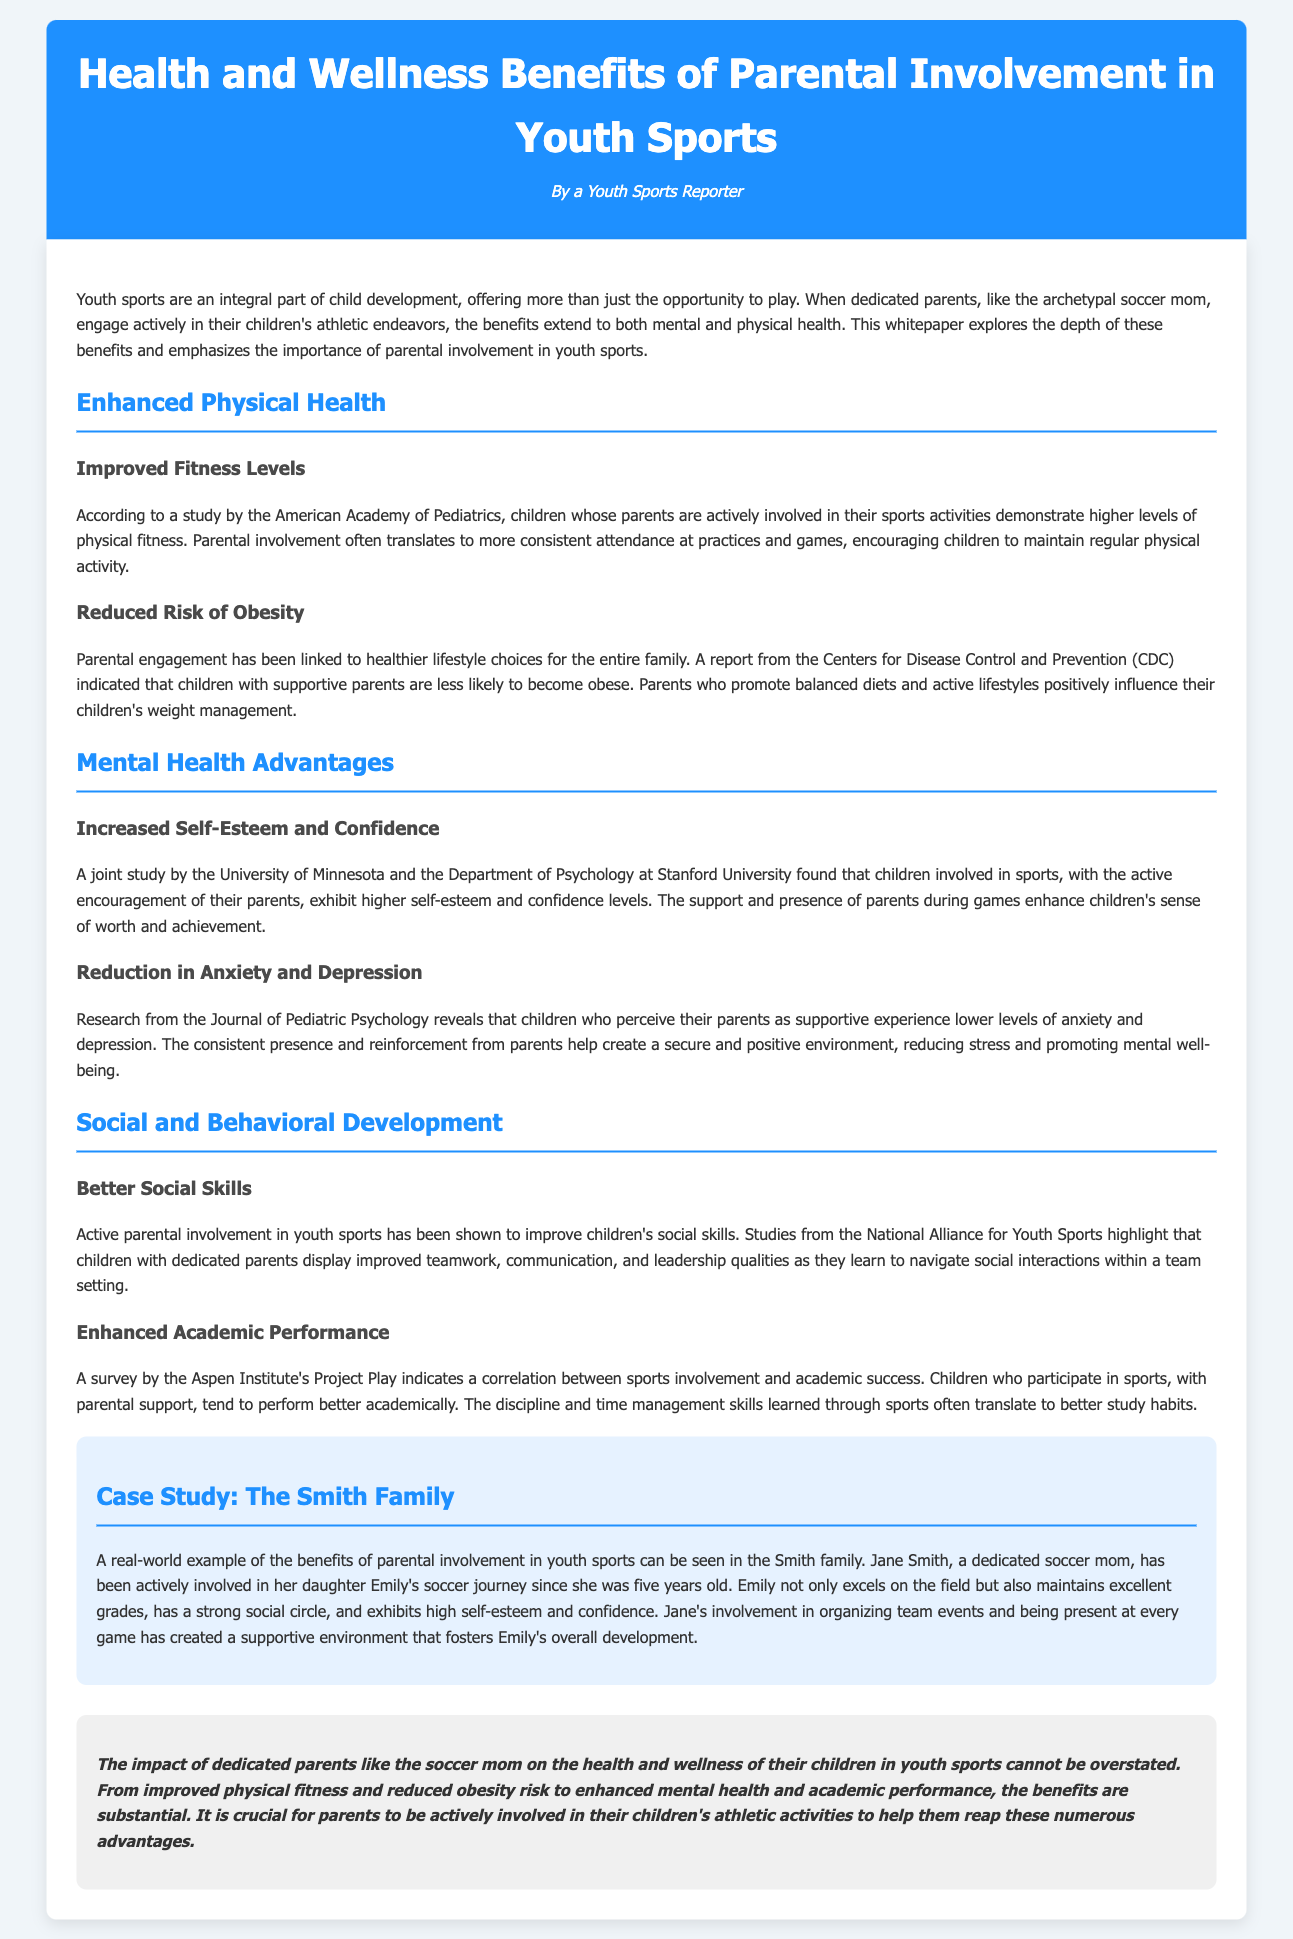what is the title of the document? The title of the document is presented prominently at the top as the header.
Answer: Health and Wellness Benefits of Parental Involvement in Youth Sports who authored the document? The document indicates the author beneath the title.
Answer: A Youth Sports Reporter which organization conducted the study on improved fitness levels? The author references a study in the document linked to a well-known organization.
Answer: American Academy of Pediatrics what is one mental health advantage of parental involvement? The document lists various mental health advantages supported by research findings.
Answer: Increased Self-Esteem and Confidence which family is highlighted as a case study in the document? The case study provides a real-world example of parental involvement from the document.
Answer: The Smith Family what benefit is associated with reduced obesity risk? The document states a specific health benefit stemming from parental engagement.
Answer: Healthier lifestyle choices how does parental involvement impact academic performance? The document describes the relationship between sports involvement and academic outcomes.
Answer: Better academic performance what psychological condition is shown to be reduced by supportive parents? The research findings in the document point to mental health effects of parental encouragement.
Answer: Anxiety and Depression what is the background color of the case study section? The document describes changes in styling and color for different sections.
Answer: Light blue 